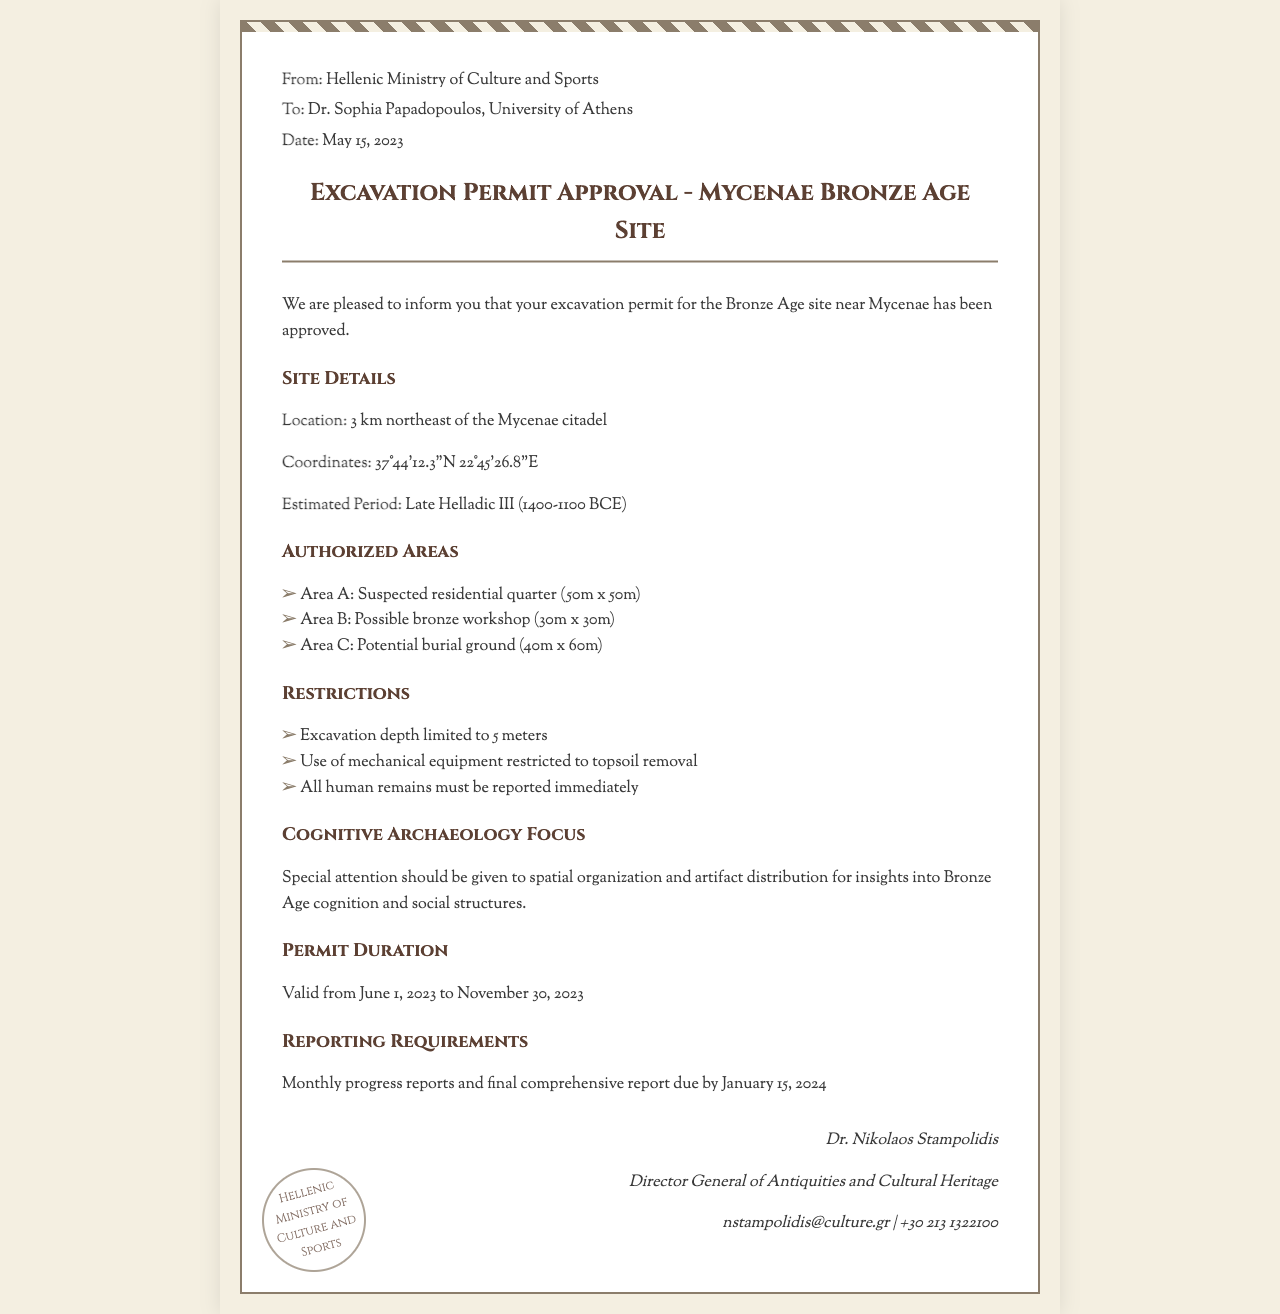What is the date of permit approval? The date is specified in the document as May 15, 2023.
Answer: May 15, 2023 What is the estimated period of the site? The document mentions that the estimated period is Late Helladic III.
Answer: Late Helladic III How deep can the excavations go? The maximum excavation depth allowed is explicitly mentioned in the restrictions section.
Answer: 5 meters What is the location of the site? The location is described in the document as 3 km northeast of the Mycenae citadel.
Answer: 3 km northeast of the Mycenae citadel Who is the director general of antiquities? The name of the director general is provided at the bottom of the document.
Answer: Dr. Nikolaos Stampolidis What is the duration of the permit? The duration is clearly stated in the permit section, covering a specific timeframe.
Answer: June 1, 2023 to November 30, 2023 What is the area of the suspected residential quarter? The dimensions of Area A are provided, which indicate its size.
Answer: 50m x 50m Why should special attention be focused on spatial organization? The document highlights the importance of spatial organization in understanding Bronze Age cognition.
Answer: Insights into Bronze Age cognition What type of document is this? The structure and content of the document indicate its type as a permit approval communication.
Answer: Excavation permit approval 